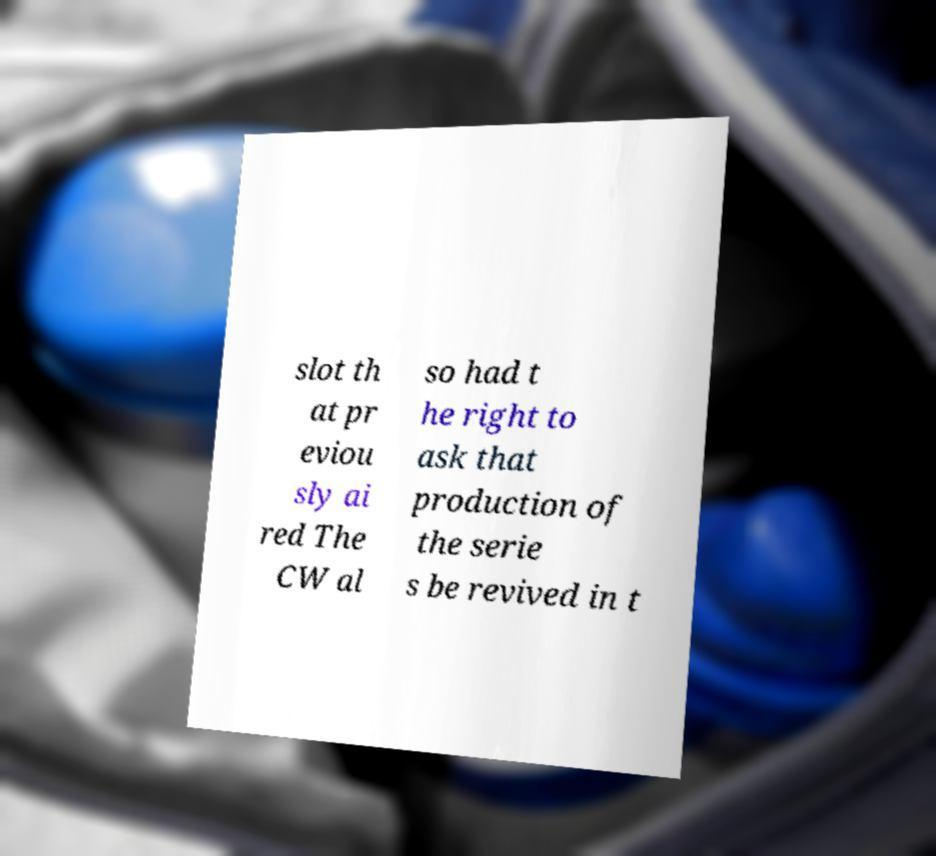I need the written content from this picture converted into text. Can you do that? slot th at pr eviou sly ai red The CW al so had t he right to ask that production of the serie s be revived in t 